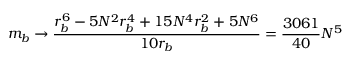<formula> <loc_0><loc_0><loc_500><loc_500>m _ { b } \rightarrow \frac { r _ { b } ^ { 6 } - 5 N ^ { 2 } r _ { b } ^ { 4 } + 1 5 N ^ { 4 } r _ { b } ^ { 2 } + 5 N ^ { 6 } } { 1 0 r _ { b } } = \frac { 3 0 6 1 } { 4 0 } N ^ { 5 }</formula> 